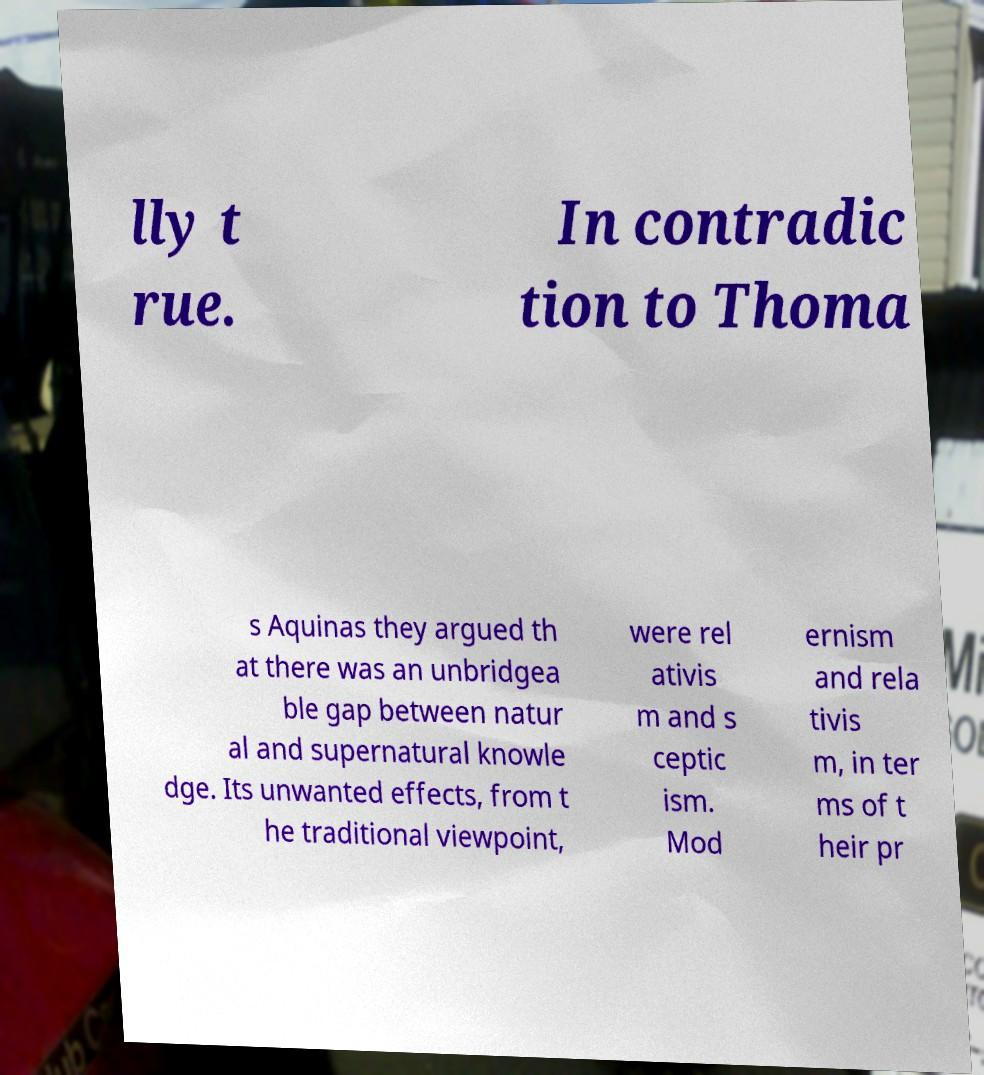For documentation purposes, I need the text within this image transcribed. Could you provide that? lly t rue. In contradic tion to Thoma s Aquinas they argued th at there was an unbridgea ble gap between natur al and supernatural knowle dge. Its unwanted effects, from t he traditional viewpoint, were rel ativis m and s ceptic ism. Mod ernism and rela tivis m, in ter ms of t heir pr 